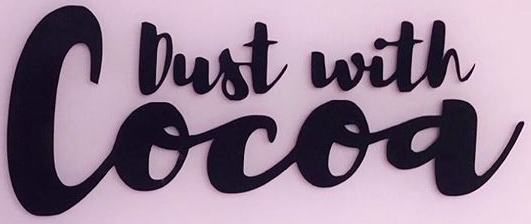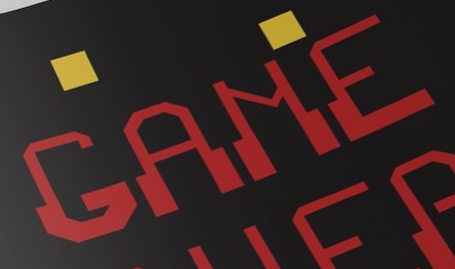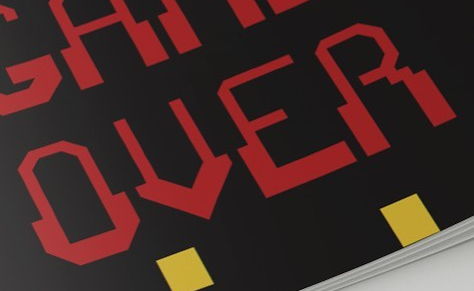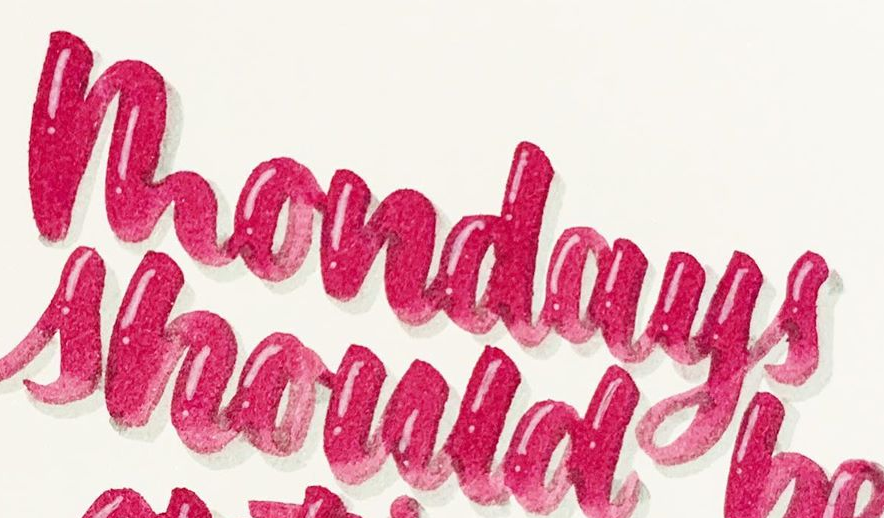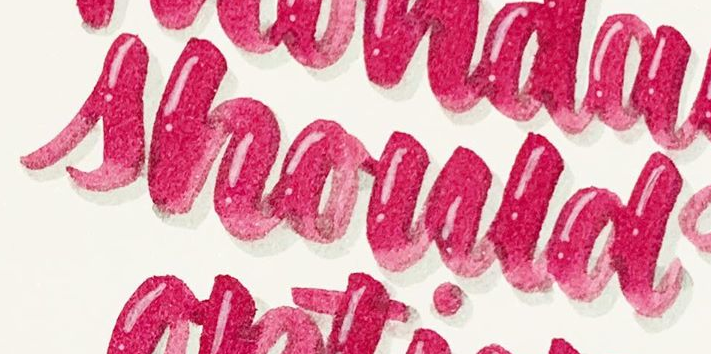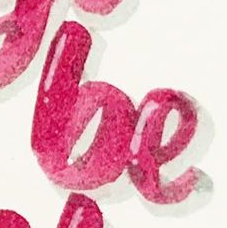What text is displayed in these images sequentially, separated by a semicolon? Cocoa; GAME; OVER; mondays; should; be 